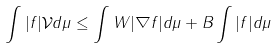Convert formula to latex. <formula><loc_0><loc_0><loc_500><loc_500>\int | f | \mathcal { V } d \mu \leq \int W | \nabla f | d \mu + B \int | f | d \mu</formula> 